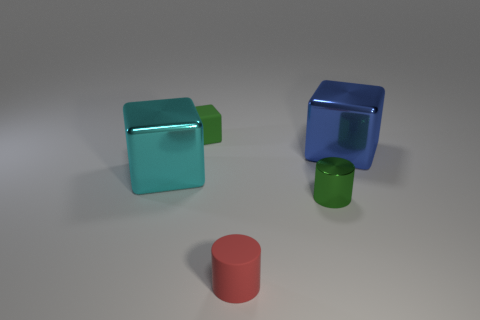Add 3 big purple matte cylinders. How many objects exist? 8 Subtract all cubes. How many objects are left? 2 Add 2 tiny cyan metal balls. How many tiny cyan metal balls exist? 2 Subtract 0 blue spheres. How many objects are left? 5 Subtract all rubber cylinders. Subtract all large blocks. How many objects are left? 2 Add 1 matte cylinders. How many matte cylinders are left? 2 